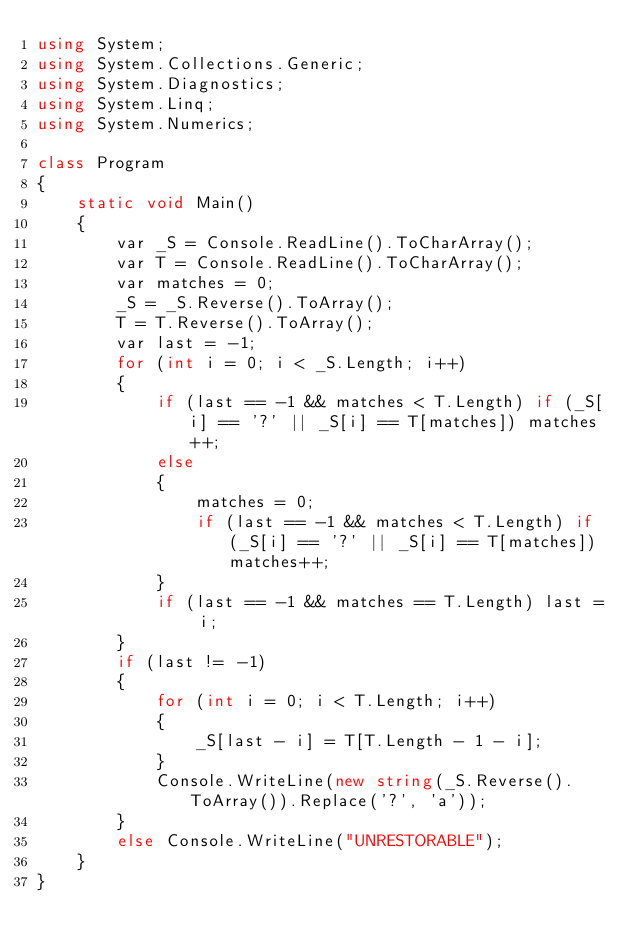<code> <loc_0><loc_0><loc_500><loc_500><_C#_>using System;
using System.Collections.Generic;
using System.Diagnostics;
using System.Linq;
using System.Numerics;
 
class Program
{
    static void Main()
    {
        var _S = Console.ReadLine().ToCharArray();
        var T = Console.ReadLine().ToCharArray();
        var matches = 0;
        _S = _S.Reverse().ToArray();
        T = T.Reverse().ToArray();
        var last = -1;
        for (int i = 0; i < _S.Length; i++)
        {
            if (last == -1 && matches < T.Length) if (_S[i] == '?' || _S[i] == T[matches]) matches++;
            else
            {
                matches = 0;
                if (last == -1 && matches < T.Length) if (_S[i] == '?' || _S[i] == T[matches]) matches++;
            }
            if (last == -1 && matches == T.Length) last = i;
        }
        if (last != -1)
        {
            for (int i = 0; i < T.Length; i++)
            {
                _S[last - i] = T[T.Length - 1 - i];
            }
            Console.WriteLine(new string(_S.Reverse().ToArray()).Replace('?', 'a'));
        }
        else Console.WriteLine("UNRESTORABLE");
    }
}</code> 